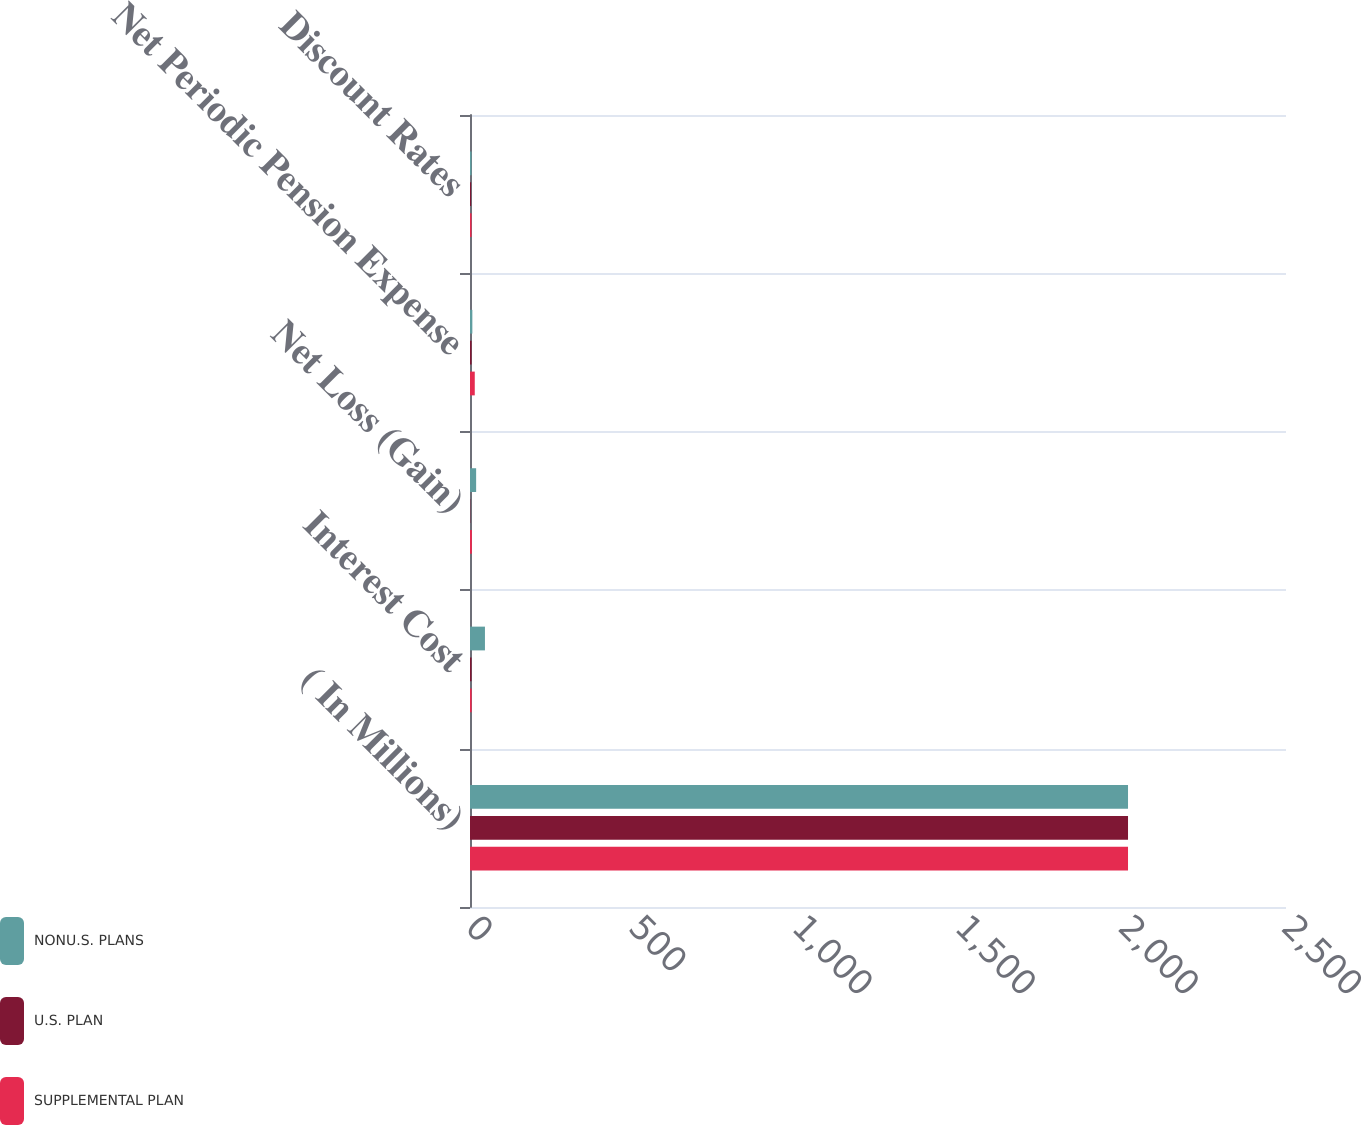<chart> <loc_0><loc_0><loc_500><loc_500><stacked_bar_chart><ecel><fcel>( In Millions)<fcel>Interest Cost<fcel>Net Loss (Gain)<fcel>Net Periodic Pension Expense<fcel>Discount Rates<nl><fcel>NONU.S. PLANS<fcel>2016<fcel>45.8<fcel>18.8<fcel>7.2<fcel>4.71<nl><fcel>U.S. PLAN<fcel>2016<fcel>4.7<fcel>1<fcel>4.8<fcel>3.39<nl><fcel>SUPPLEMENTAL PLAN<fcel>2016<fcel>5.1<fcel>5.8<fcel>14.6<fcel>4.71<nl></chart> 